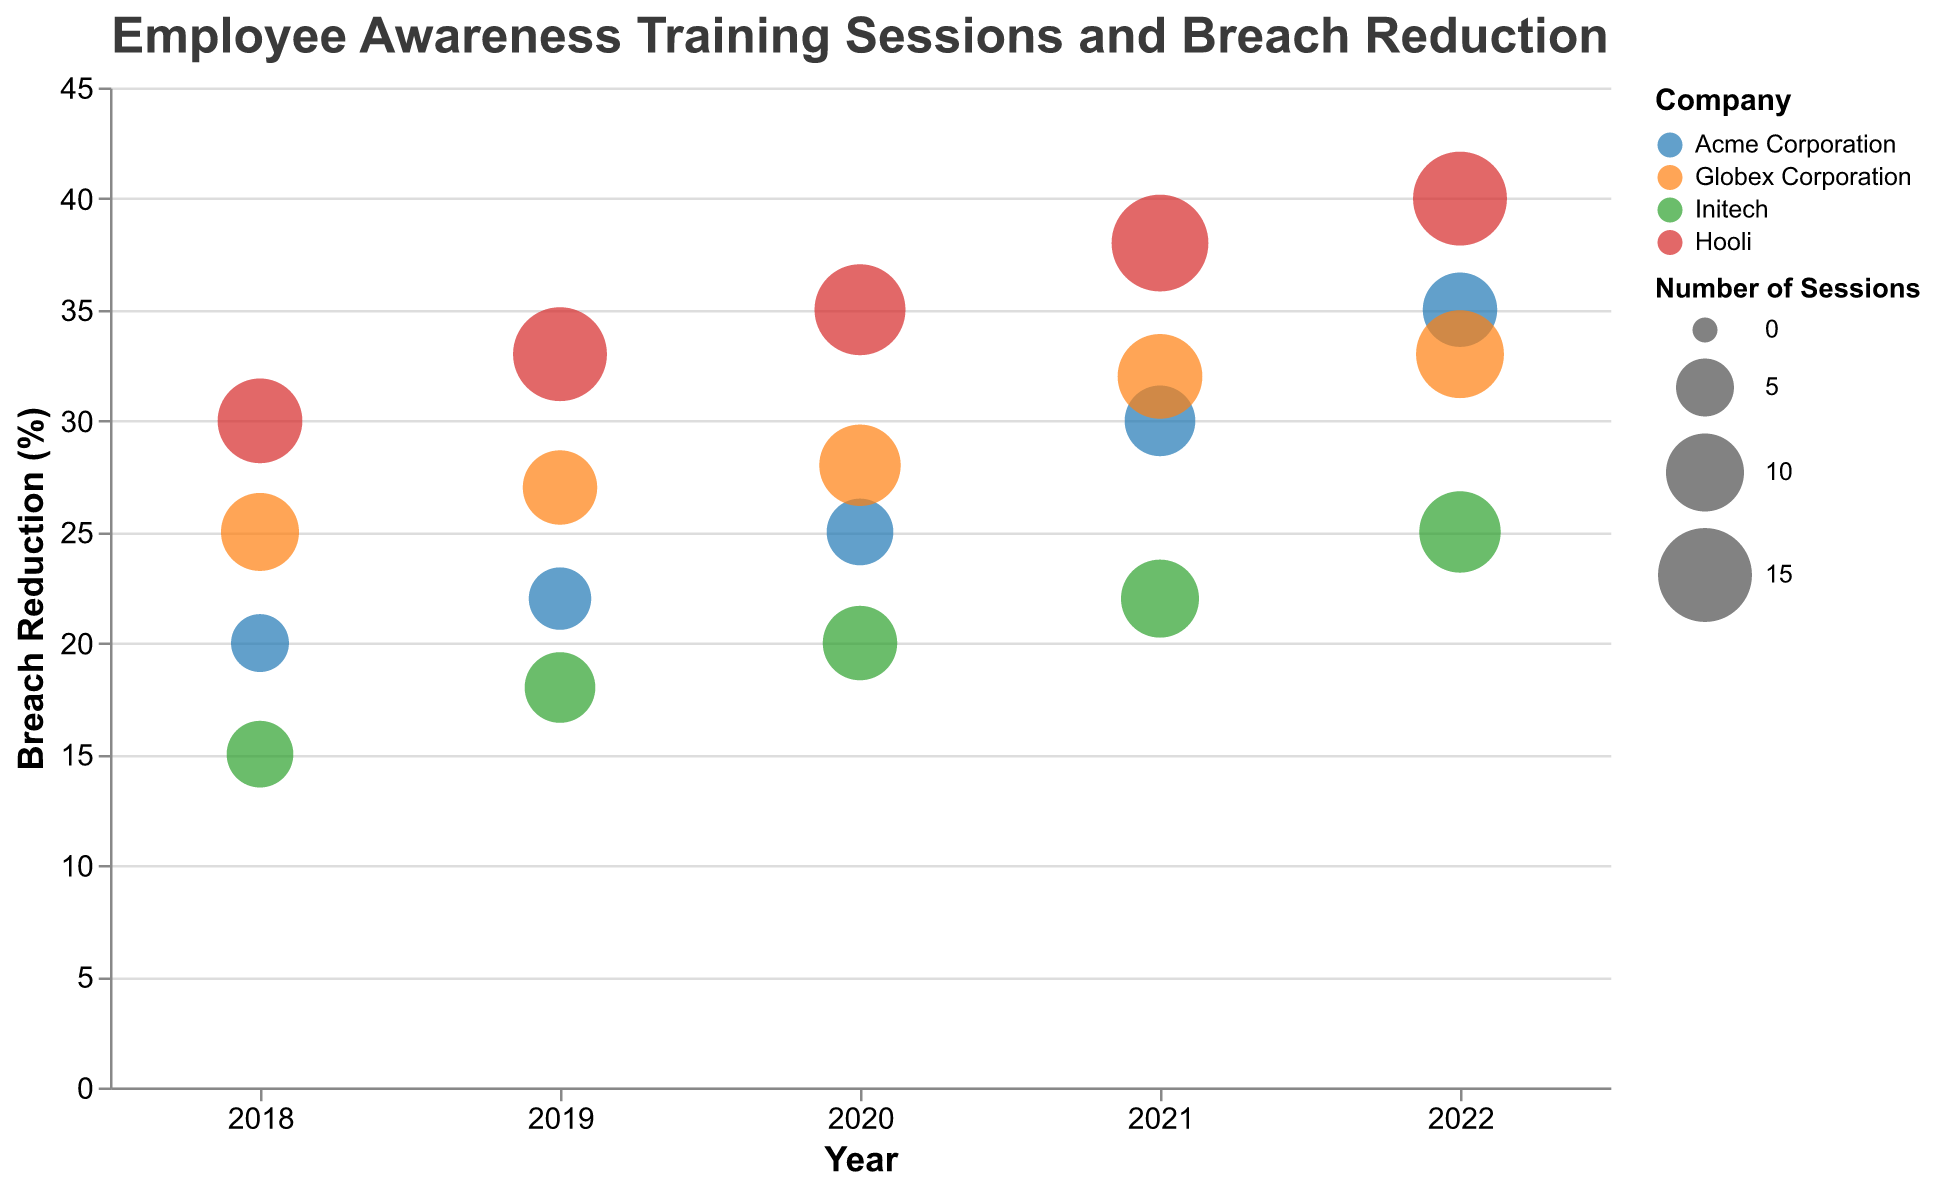What company had the highest breach reduction in 2020? The company with the highest breach reduction in 2020 is determined by looking at the y-axis value for each company in 2020. Hooli has the highest breach reduction at 35%.
Answer: Hooli How many sessions did Globex Corporation conduct in 2018? Find the bubble corresponding to Globex Corporation in the year 2018 and check its size, which signifies the number of sessions. Globex conducted 10 sessions.
Answer: 10 Which company saw the greatest increase in breach reduction from 2018 to 2022? Compare the breach reduction values from 2018 to 2022 for each company. Hooli's breach reduction increased from 30% to 40%, which is the highest increase (10%).
Answer: Hooli Between Acme Corporation and Initech, which company conducted more training sessions in 2021? For the year 2021, compare the bubble sizes of Acme Corporation and Initech. Acme conducted 8 sessions and Initech conducted 10 sessions.
Answer: Initech What is the average breach reduction across all companies in 2019? Sum the breach reduction percentages for all companies in 2019 and divide by 4 (the number of companies). (22 + 27 + 18 + 33) / 4 = 25%.
Answer: 25% Did any company achieve a breach reduction of 35% before 2020? Look at the y-axis values for all companies for the years 2018 and 2019. None of the companies achieved a 35% breach reduction before 2020.
Answer: No Which company had the least number of training sessions in 2019? Find the smallest bubble for the year 2019. Acme Corporation conducted the least number of sessions with 6.
Answer: Acme Corporation How many training sessions did Hooli conduct over the years 2020 to 2022? Sum the number of sessions Hooli conducted in 2020, 2021, and 2022. 14 + 16 + 15 = 45.
Answer: 45 